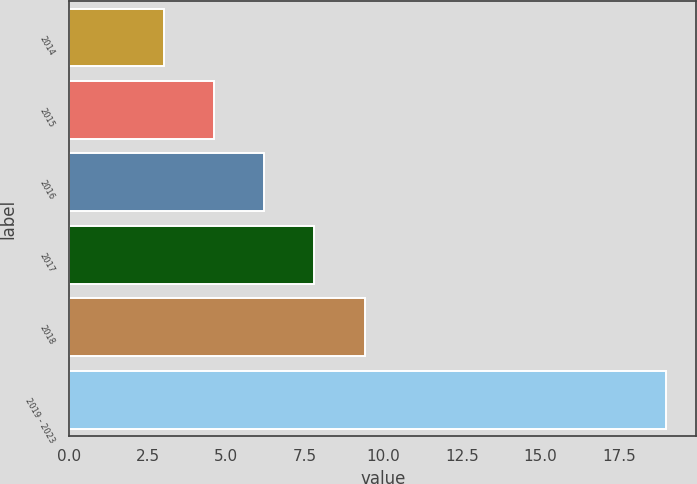Convert chart. <chart><loc_0><loc_0><loc_500><loc_500><bar_chart><fcel>2014<fcel>2015<fcel>2016<fcel>2017<fcel>2018<fcel>2019 - 2023<nl><fcel>3<fcel>4.6<fcel>6.2<fcel>7.8<fcel>9.4<fcel>19<nl></chart> 